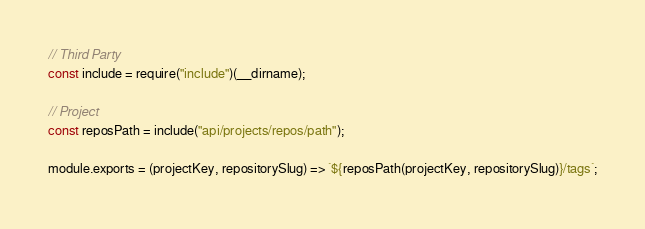Convert code to text. <code><loc_0><loc_0><loc_500><loc_500><_JavaScript_>// Third Party
const include = require("include")(__dirname);

// Project
const reposPath = include("api/projects/repos/path");

module.exports = (projectKey, repositorySlug) => `${reposPath(projectKey, repositorySlug)}/tags`;
</code> 